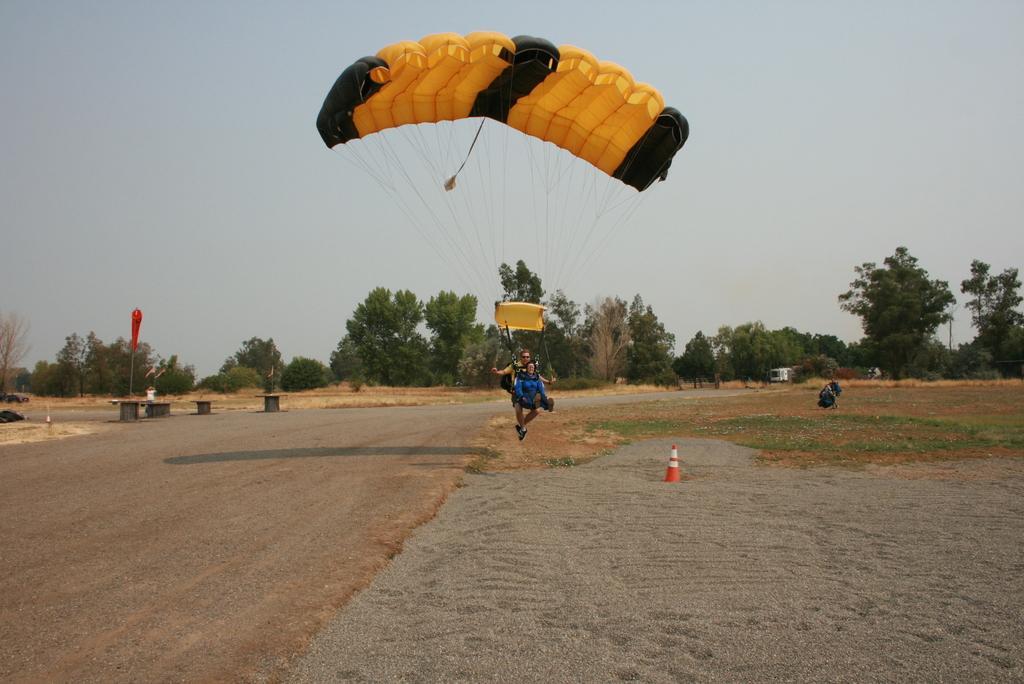In one or two sentences, can you explain what this image depicts? In this image I can see two persons are flying in the air and I can see a parachute which is yellow and black in color and few ropes tied to the parachute and the persons. I can see a traffic pole, the ground and few trees. In the background I can see the sky. 